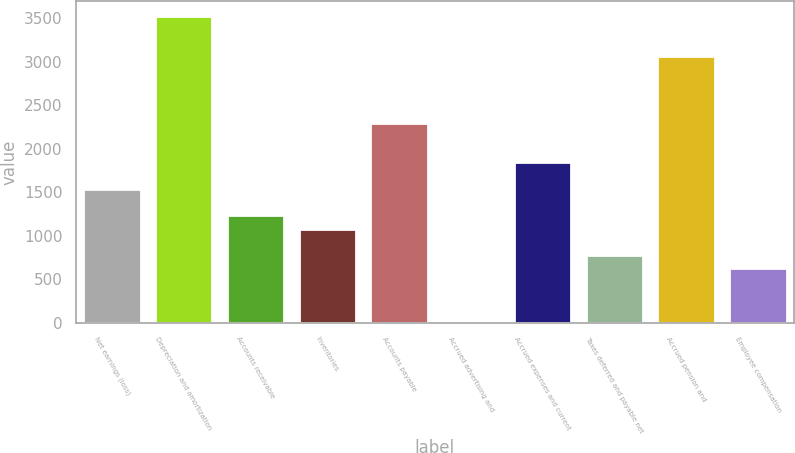Convert chart to OTSL. <chart><loc_0><loc_0><loc_500><loc_500><bar_chart><fcel>Net earnings (loss)<fcel>Depreciation and amortization<fcel>Accounts receivable<fcel>Inventories<fcel>Accounts payable<fcel>Accrued advertising and<fcel>Accrued expenses and current<fcel>Taxes deferred and payable net<fcel>Accrued pension and<fcel>Employee compensation<nl><fcel>1538<fcel>3521.8<fcel>1232.8<fcel>1080.2<fcel>2301<fcel>12<fcel>1843.2<fcel>775<fcel>3064<fcel>622.4<nl></chart> 